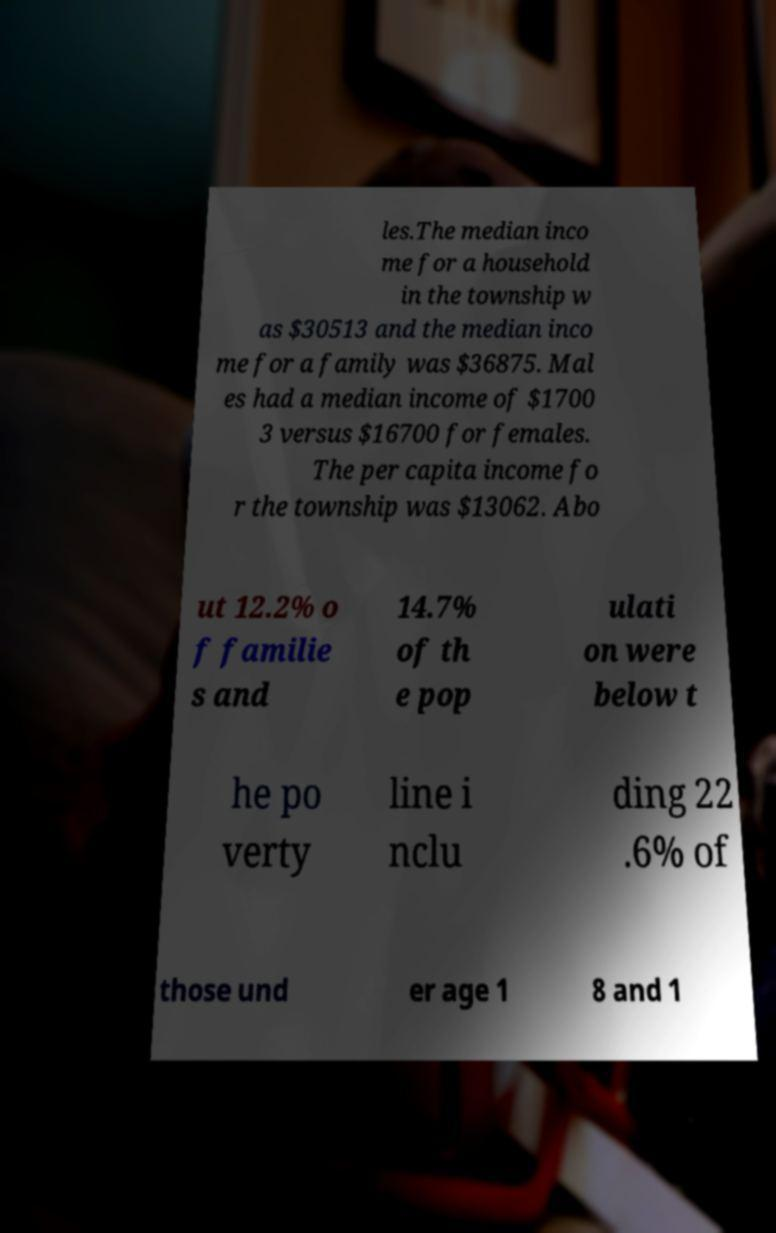What messages or text are displayed in this image? I need them in a readable, typed format. les.The median inco me for a household in the township w as $30513 and the median inco me for a family was $36875. Mal es had a median income of $1700 3 versus $16700 for females. The per capita income fo r the township was $13062. Abo ut 12.2% o f familie s and 14.7% of th e pop ulati on were below t he po verty line i nclu ding 22 .6% of those und er age 1 8 and 1 